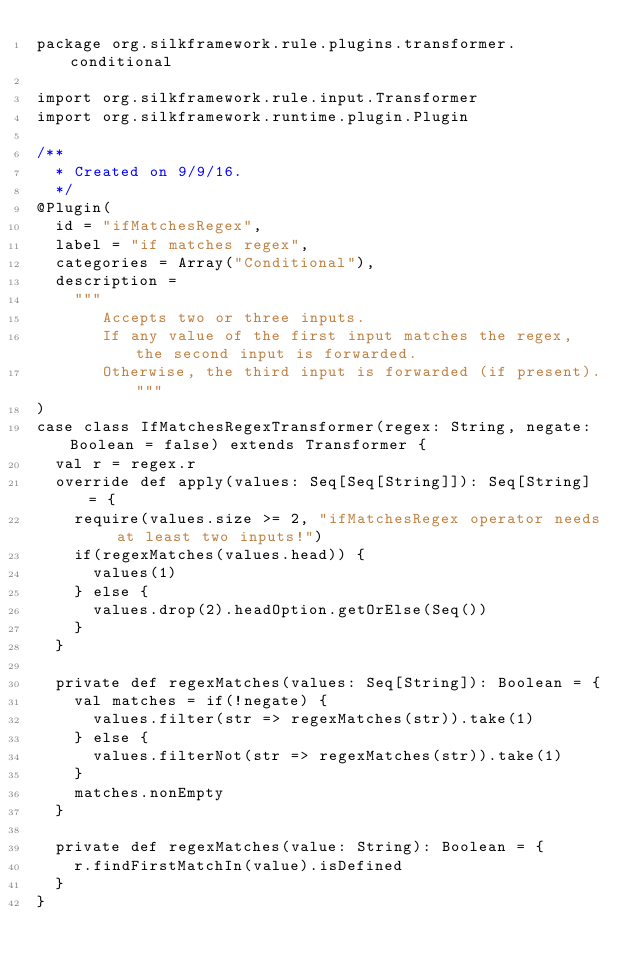Convert code to text. <code><loc_0><loc_0><loc_500><loc_500><_Scala_>package org.silkframework.rule.plugins.transformer.conditional

import org.silkframework.rule.input.Transformer
import org.silkframework.runtime.plugin.Plugin

/**
  * Created on 9/9/16.
  */
@Plugin(
  id = "ifMatchesRegex",
  label = "if matches regex",
  categories = Array("Conditional"),
  description =
    """
       Accepts two or three inputs.
       If any value of the first input matches the regex, the second input is forwarded.
       Otherwise, the third input is forwarded (if present)."""
)
case class IfMatchesRegexTransformer(regex: String, negate: Boolean = false) extends Transformer {
  val r = regex.r
  override def apply(values: Seq[Seq[String]]): Seq[String] = {
    require(values.size >= 2, "ifMatchesRegex operator needs at least two inputs!")
    if(regexMatches(values.head)) {
      values(1)
    } else {
      values.drop(2).headOption.getOrElse(Seq())
    }
  }

  private def regexMatches(values: Seq[String]): Boolean = {
    val matches = if(!negate) {
      values.filter(str => regexMatches(str)).take(1)
    } else {
      values.filterNot(str => regexMatches(str)).take(1)
    }
    matches.nonEmpty
  }

  private def regexMatches(value: String): Boolean = {
    r.findFirstMatchIn(value).isDefined
  }
}
</code> 